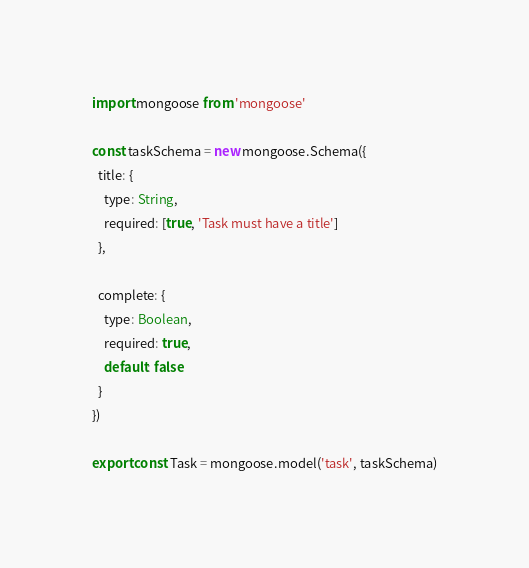<code> <loc_0><loc_0><loc_500><loc_500><_JavaScript_>import mongoose from 'mongoose'

const taskSchema = new mongoose.Schema({
  title: {
    type: String,
    required: [true, 'Task must have a title']
  },

  complete: {
    type: Boolean,
    required: true,
    default: false
  }
})

export const Task = mongoose.model('task', taskSchema)
</code> 